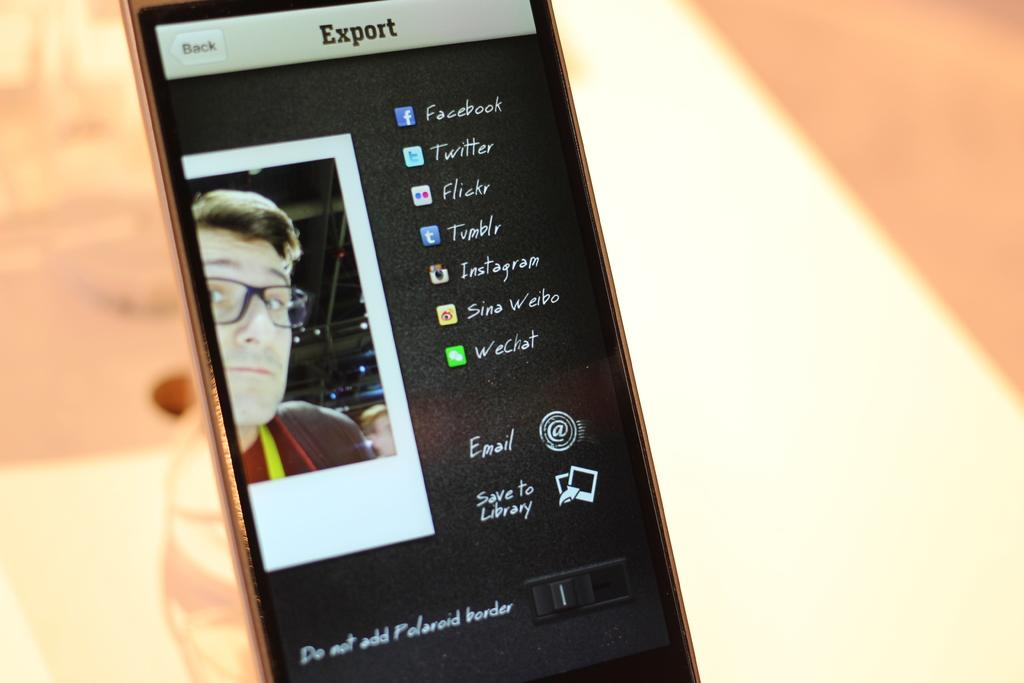<image>
Give a short and clear explanation of the subsequent image. A smarphone running an app that allows the user to Export to various social media outlets. 